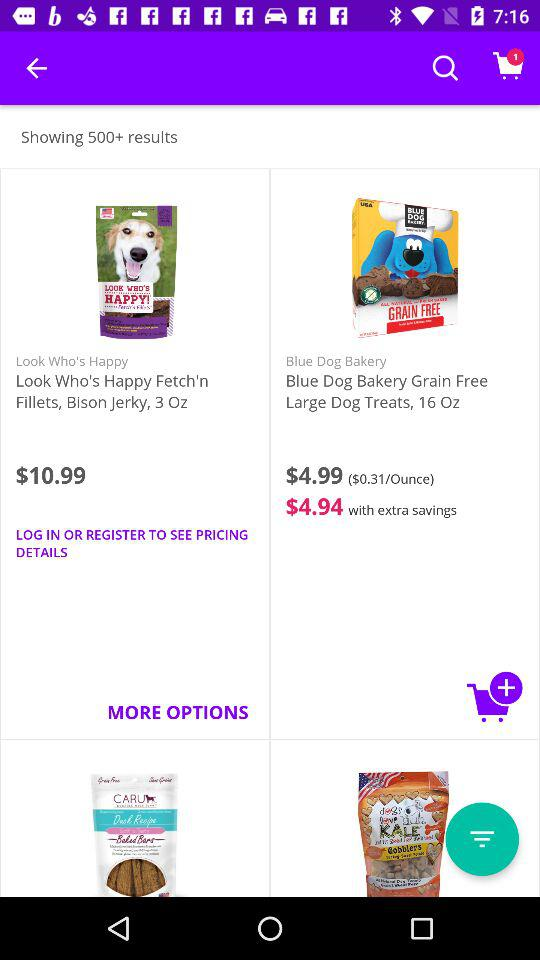What is the original price of "Blue Dog Bakery Grain Free Large Dog Treats, 16 Oz"? The original price is $4.99. 